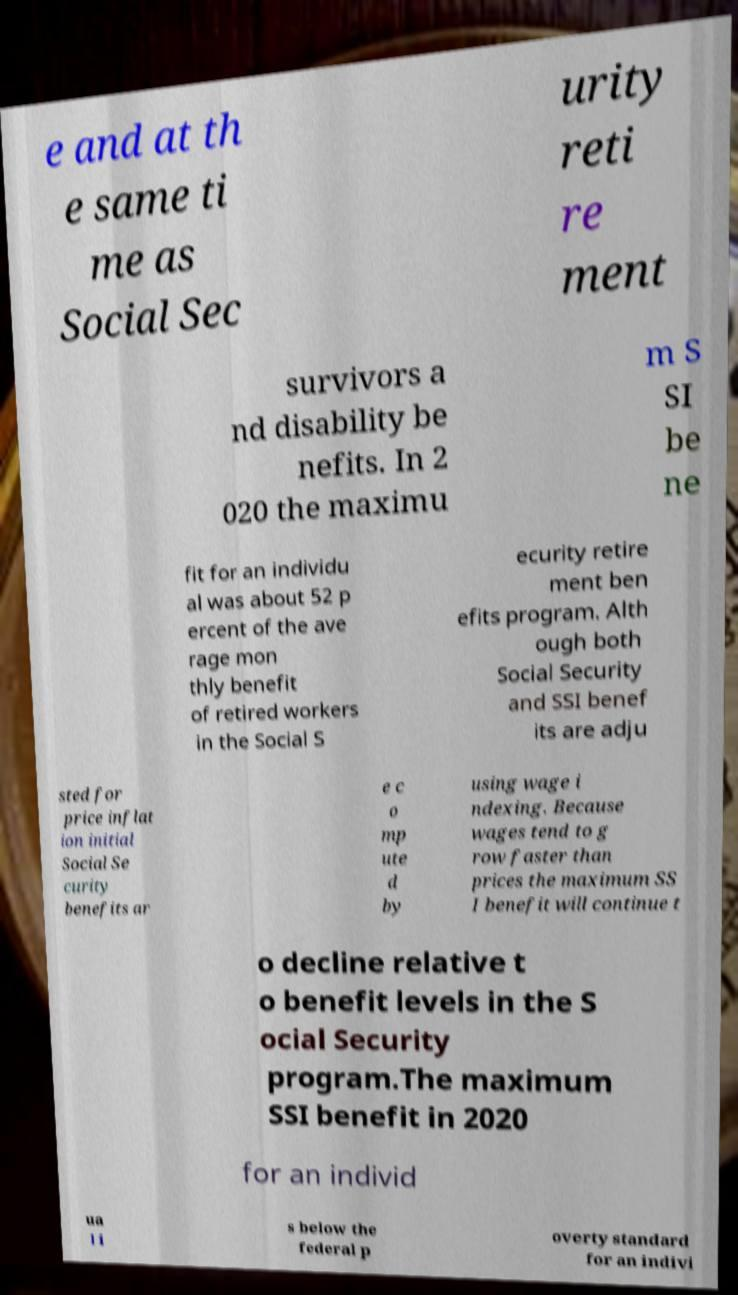I need the written content from this picture converted into text. Can you do that? e and at th e same ti me as Social Sec urity reti re ment survivors a nd disability be nefits. In 2 020 the maximu m S SI be ne fit for an individu al was about 52 p ercent of the ave rage mon thly benefit of retired workers in the Social S ecurity retire ment ben efits program. Alth ough both Social Security and SSI benef its are adju sted for price inflat ion initial Social Se curity benefits ar e c o mp ute d by using wage i ndexing. Because wages tend to g row faster than prices the maximum SS I benefit will continue t o decline relative t o benefit levels in the S ocial Security program.The maximum SSI benefit in 2020 for an individ ua l i s below the federal p overty standard for an indivi 